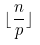<formula> <loc_0><loc_0><loc_500><loc_500>\lfloor \frac { n } { p } \rfloor</formula> 